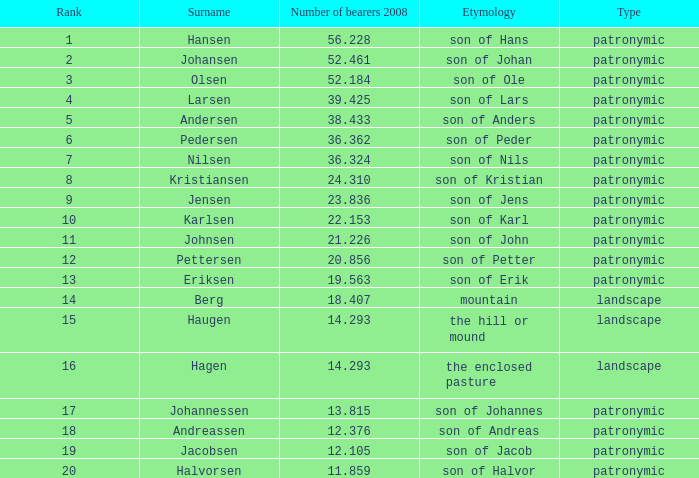What is the highest Number of Bearers 2008, when Surname is Hansen, and when Rank is less than 1? None. Give me the full table as a dictionary. {'header': ['Rank', 'Surname', 'Number of bearers 2008', 'Etymology', 'Type'], 'rows': [['1', 'Hansen', '56.228', 'son of Hans', 'patronymic'], ['2', 'Johansen', '52.461', 'son of Johan', 'patronymic'], ['3', 'Olsen', '52.184', 'son of Ole', 'patronymic'], ['4', 'Larsen', '39.425', 'son of Lars', 'patronymic'], ['5', 'Andersen', '38.433', 'son of Anders', 'patronymic'], ['6', 'Pedersen', '36.362', 'son of Peder', 'patronymic'], ['7', 'Nilsen', '36.324', 'son of Nils', 'patronymic'], ['8', 'Kristiansen', '24.310', 'son of Kristian', 'patronymic'], ['9', 'Jensen', '23.836', 'son of Jens', 'patronymic'], ['10', 'Karlsen', '22.153', 'son of Karl', 'patronymic'], ['11', 'Johnsen', '21.226', 'son of John', 'patronymic'], ['12', 'Pettersen', '20.856', 'son of Petter', 'patronymic'], ['13', 'Eriksen', '19.563', 'son of Erik', 'patronymic'], ['14', 'Berg', '18.407', 'mountain', 'landscape'], ['15', 'Haugen', '14.293', 'the hill or mound', 'landscape'], ['16', 'Hagen', '14.293', 'the enclosed pasture', 'landscape'], ['17', 'Johannessen', '13.815', 'son of Johannes', 'patronymic'], ['18', 'Andreassen', '12.376', 'son of Andreas', 'patronymic'], ['19', 'Jacobsen', '12.105', 'son of Jacob', 'patronymic'], ['20', 'Halvorsen', '11.859', 'son of Halvor', 'patronymic']]} 